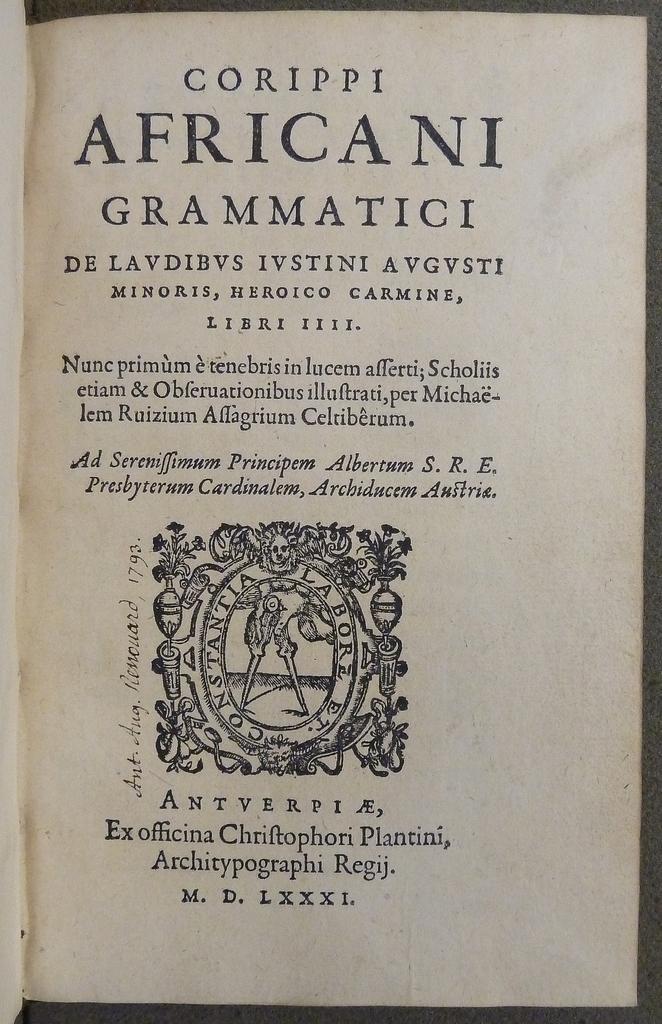<image>
Create a compact narrative representing the image presented. A page from the book Corippie Africani  Grammatici is shown. 